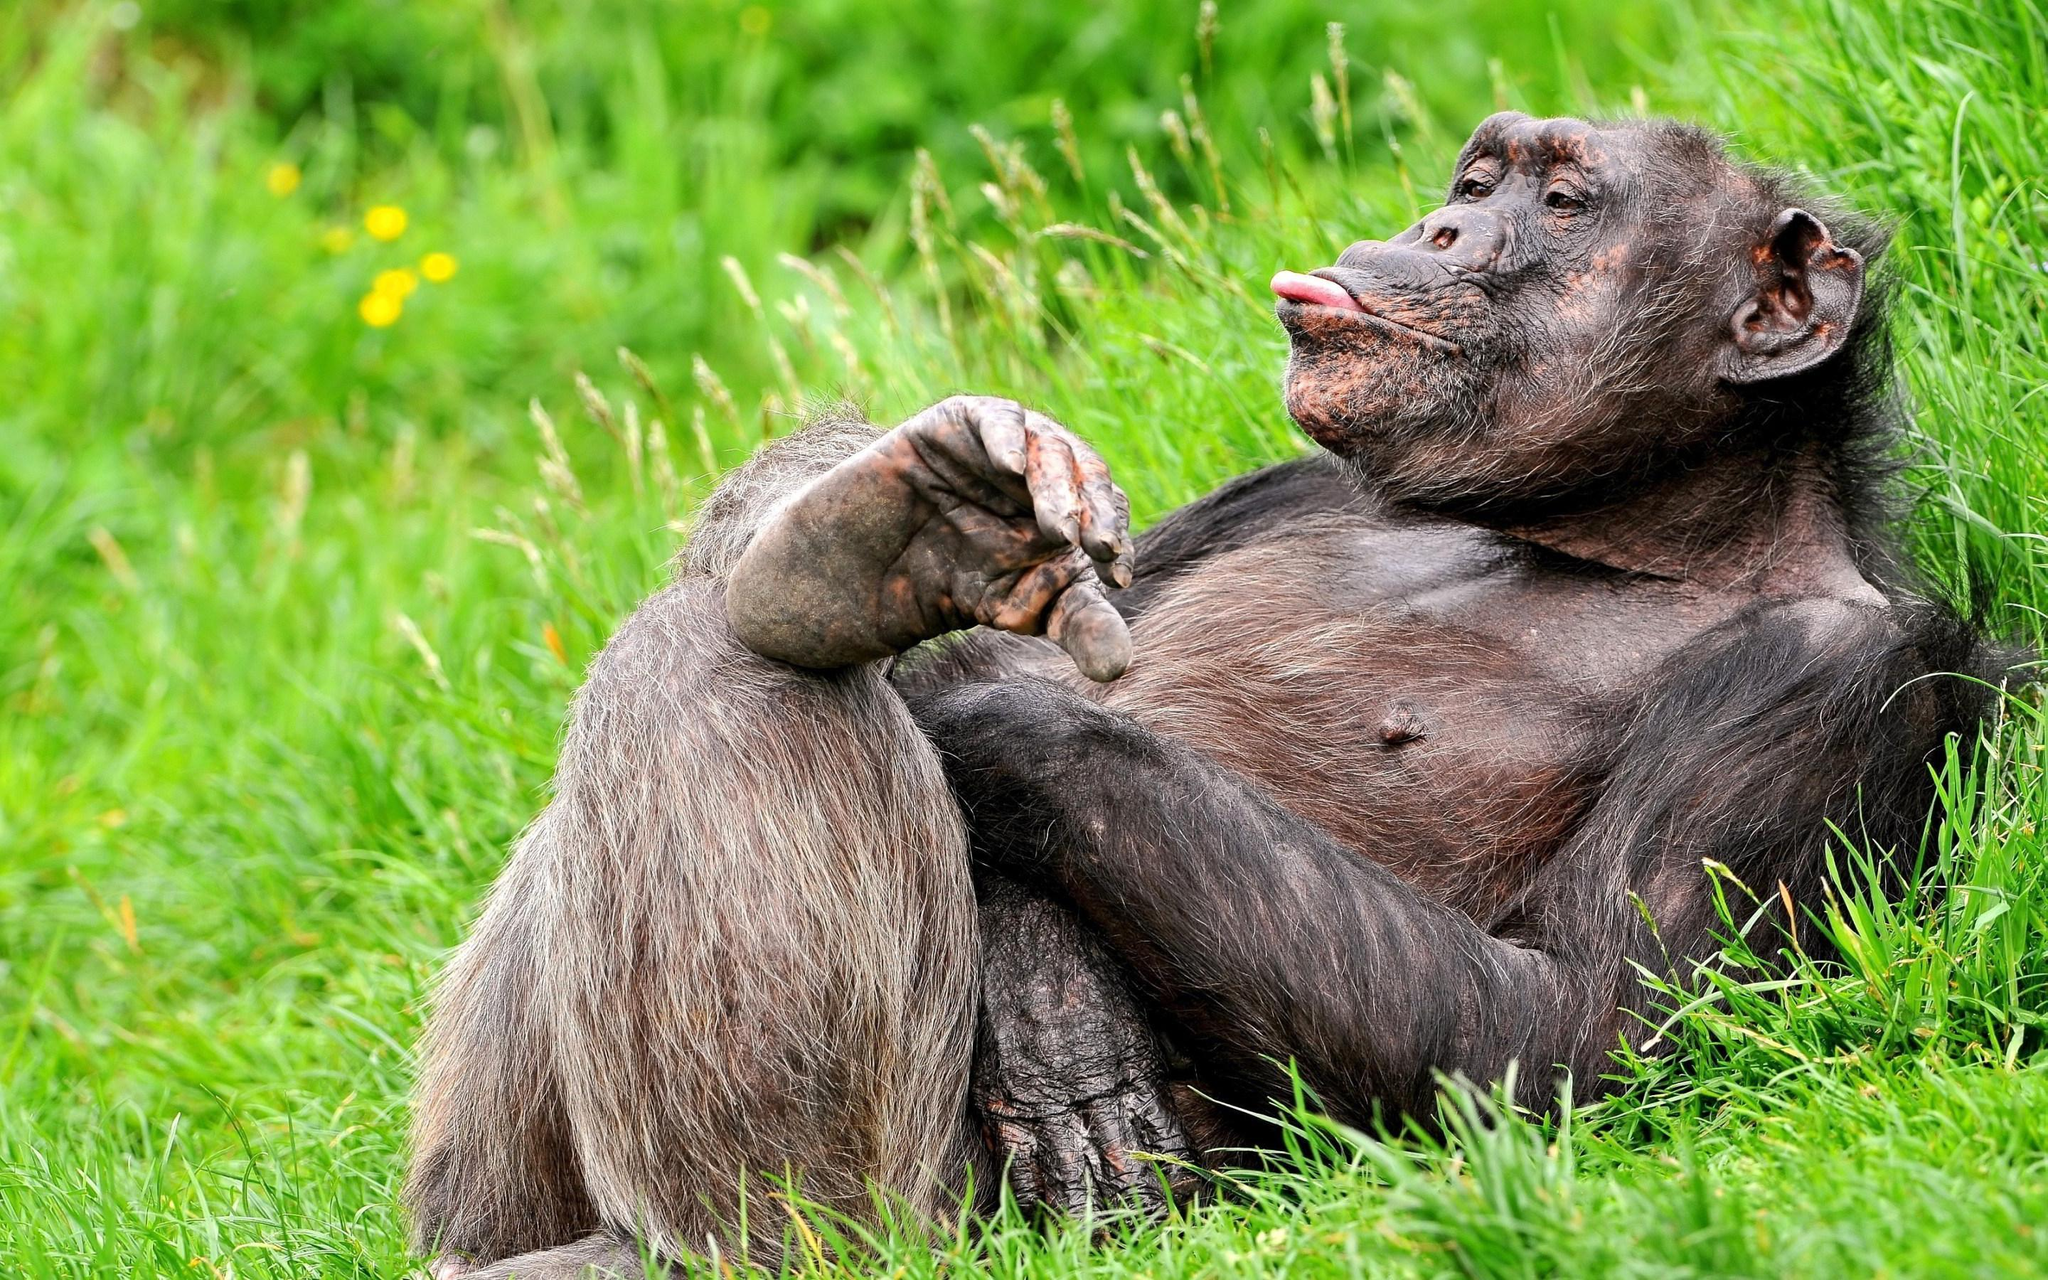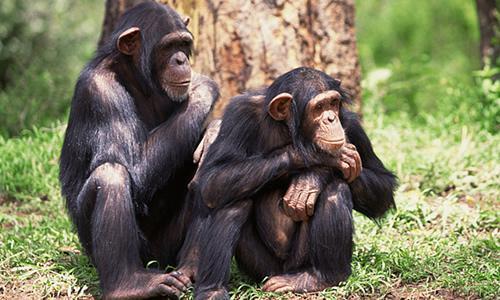The first image is the image on the left, the second image is the image on the right. Examine the images to the left and right. Is the description "There is exactly one monkey in the image on the left." accurate? Answer yes or no. Yes. The first image is the image on the left, the second image is the image on the right. For the images shown, is this caption "Two chimps of the same approximate size and age are present in the right image." true? Answer yes or no. Yes. 